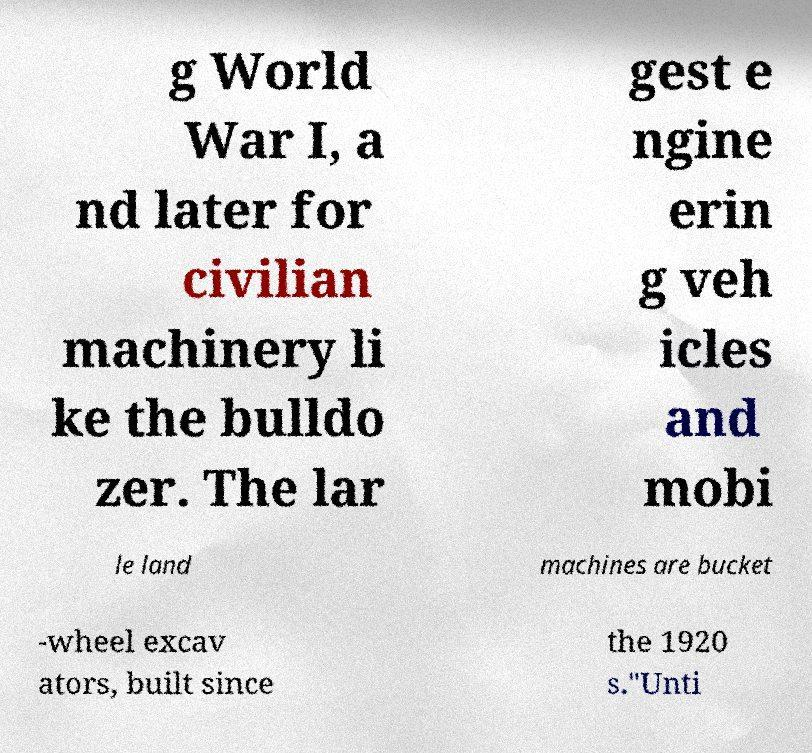Could you extract and type out the text from this image? g World War I, a nd later for civilian machinery li ke the bulldo zer. The lar gest e ngine erin g veh icles and mobi le land machines are bucket -wheel excav ators, built since the 1920 s."Unti 